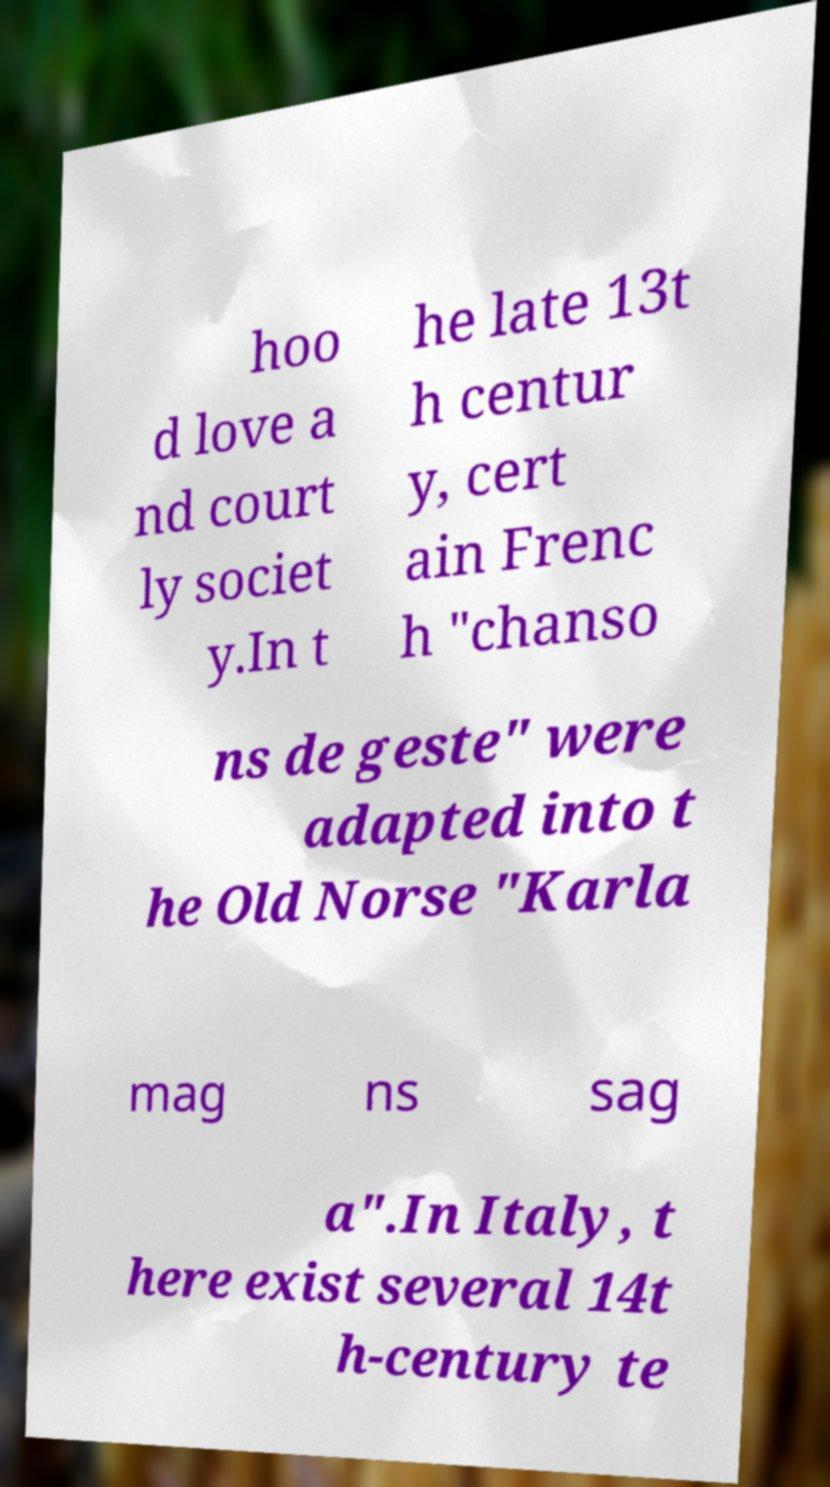Could you extract and type out the text from this image? hoo d love a nd court ly societ y.In t he late 13t h centur y, cert ain Frenc h "chanso ns de geste" were adapted into t he Old Norse "Karla mag ns sag a".In Italy, t here exist several 14t h-century te 